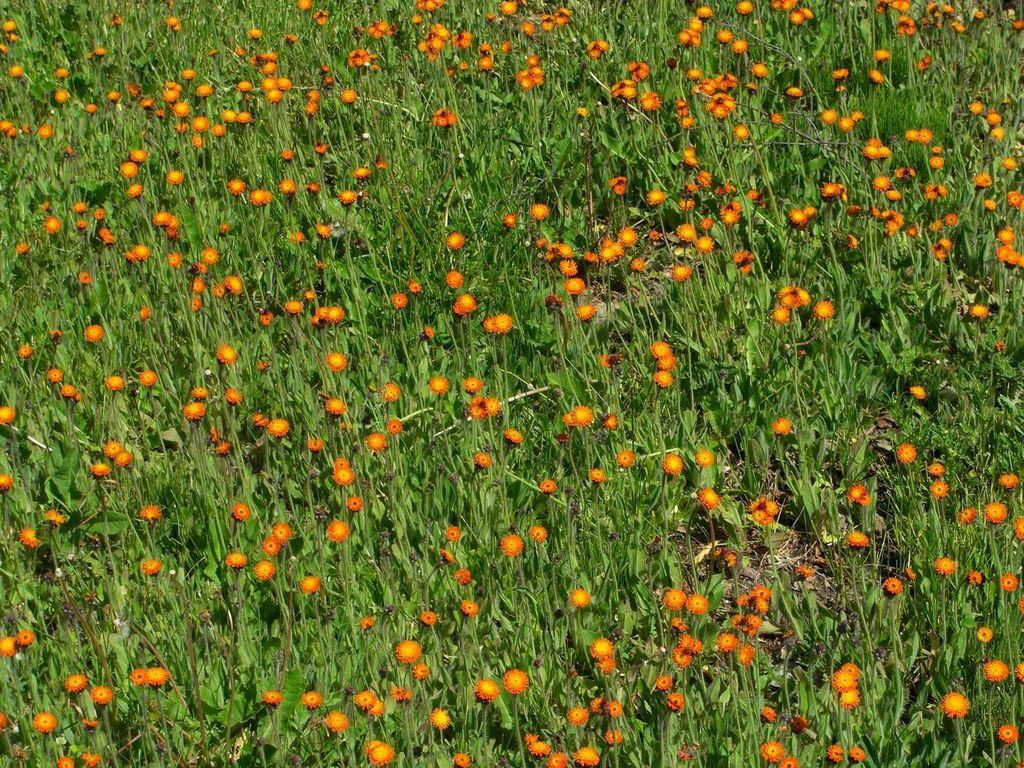What type of plants are in the image? There are flower plants in the image. What colors are the flowers? The flowers are orange and yellow in color. Where is the boy holding the umbrella in the image? There is no boy or umbrella present in the image; it only features flower plants with orange and yellow flowers. 